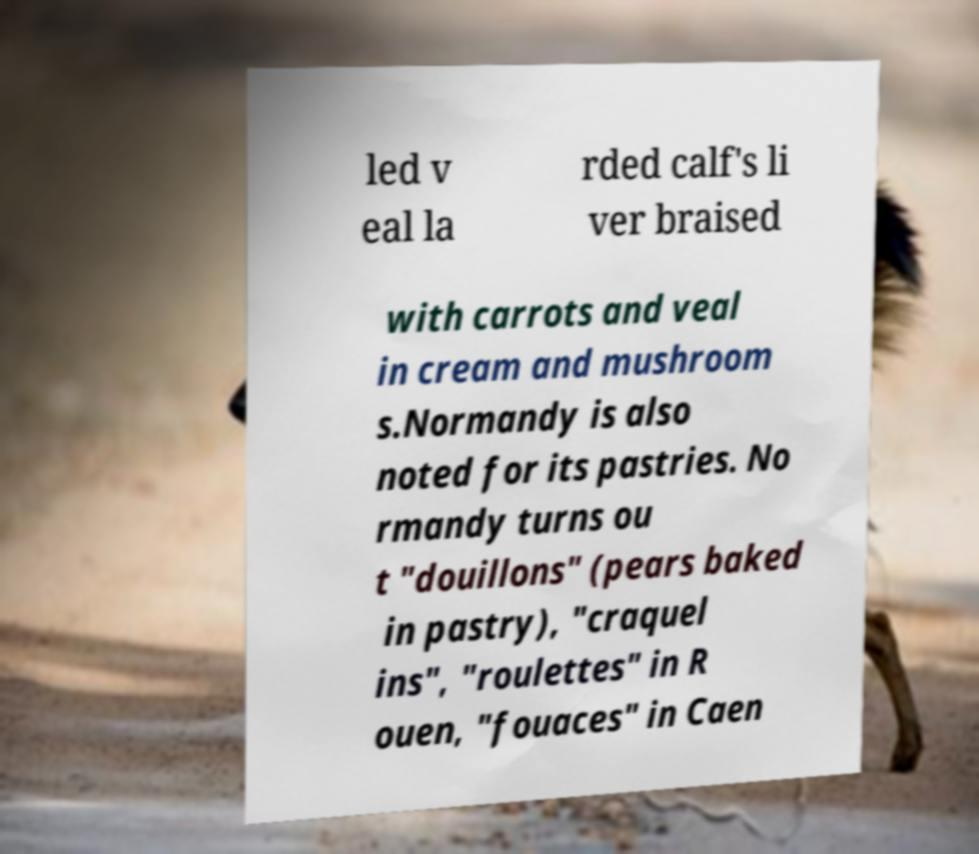I need the written content from this picture converted into text. Can you do that? led v eal la rded calf's li ver braised with carrots and veal in cream and mushroom s.Normandy is also noted for its pastries. No rmandy turns ou t "douillons" (pears baked in pastry), "craquel ins", "roulettes" in R ouen, "fouaces" in Caen 